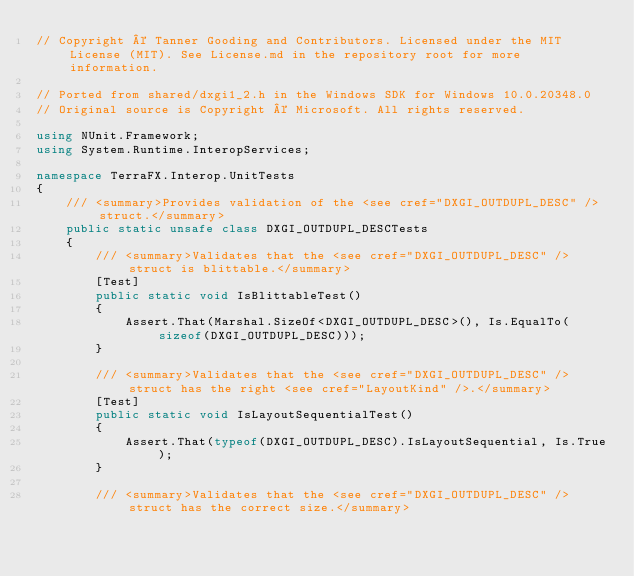Convert code to text. <code><loc_0><loc_0><loc_500><loc_500><_C#_>// Copyright © Tanner Gooding and Contributors. Licensed under the MIT License (MIT). See License.md in the repository root for more information.

// Ported from shared/dxgi1_2.h in the Windows SDK for Windows 10.0.20348.0
// Original source is Copyright © Microsoft. All rights reserved.

using NUnit.Framework;
using System.Runtime.InteropServices;

namespace TerraFX.Interop.UnitTests
{
    /// <summary>Provides validation of the <see cref="DXGI_OUTDUPL_DESC" /> struct.</summary>
    public static unsafe class DXGI_OUTDUPL_DESCTests
    {
        /// <summary>Validates that the <see cref="DXGI_OUTDUPL_DESC" /> struct is blittable.</summary>
        [Test]
        public static void IsBlittableTest()
        {
            Assert.That(Marshal.SizeOf<DXGI_OUTDUPL_DESC>(), Is.EqualTo(sizeof(DXGI_OUTDUPL_DESC)));
        }

        /// <summary>Validates that the <see cref="DXGI_OUTDUPL_DESC" /> struct has the right <see cref="LayoutKind" />.</summary>
        [Test]
        public static void IsLayoutSequentialTest()
        {
            Assert.That(typeof(DXGI_OUTDUPL_DESC).IsLayoutSequential, Is.True);
        }

        /// <summary>Validates that the <see cref="DXGI_OUTDUPL_DESC" /> struct has the correct size.</summary></code> 